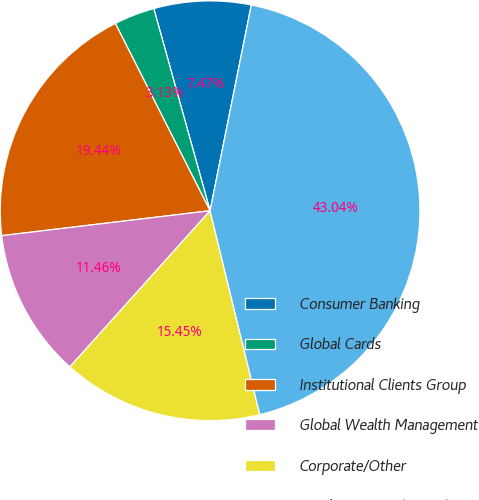Convert chart. <chart><loc_0><loc_0><loc_500><loc_500><pie_chart><fcel>Consumer Banking<fcel>Global Cards<fcel>Institutional Clients Group<fcel>Global Wealth Management<fcel>Corporate/Other<fcel>Total Citigroup (pretax)<nl><fcel>7.47%<fcel>3.13%<fcel>19.44%<fcel>11.46%<fcel>15.45%<fcel>43.04%<nl></chart> 